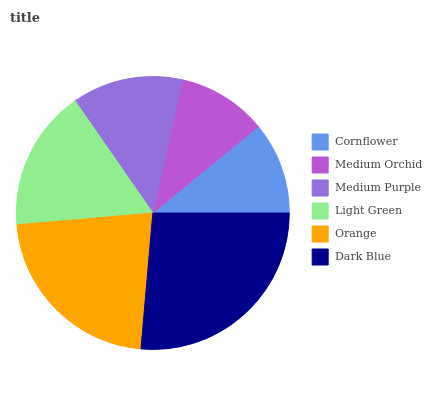Is Medium Orchid the minimum?
Answer yes or no. Yes. Is Dark Blue the maximum?
Answer yes or no. Yes. Is Medium Purple the minimum?
Answer yes or no. No. Is Medium Purple the maximum?
Answer yes or no. No. Is Medium Purple greater than Medium Orchid?
Answer yes or no. Yes. Is Medium Orchid less than Medium Purple?
Answer yes or no. Yes. Is Medium Orchid greater than Medium Purple?
Answer yes or no. No. Is Medium Purple less than Medium Orchid?
Answer yes or no. No. Is Light Green the high median?
Answer yes or no. Yes. Is Medium Purple the low median?
Answer yes or no. Yes. Is Medium Purple the high median?
Answer yes or no. No. Is Medium Orchid the low median?
Answer yes or no. No. 